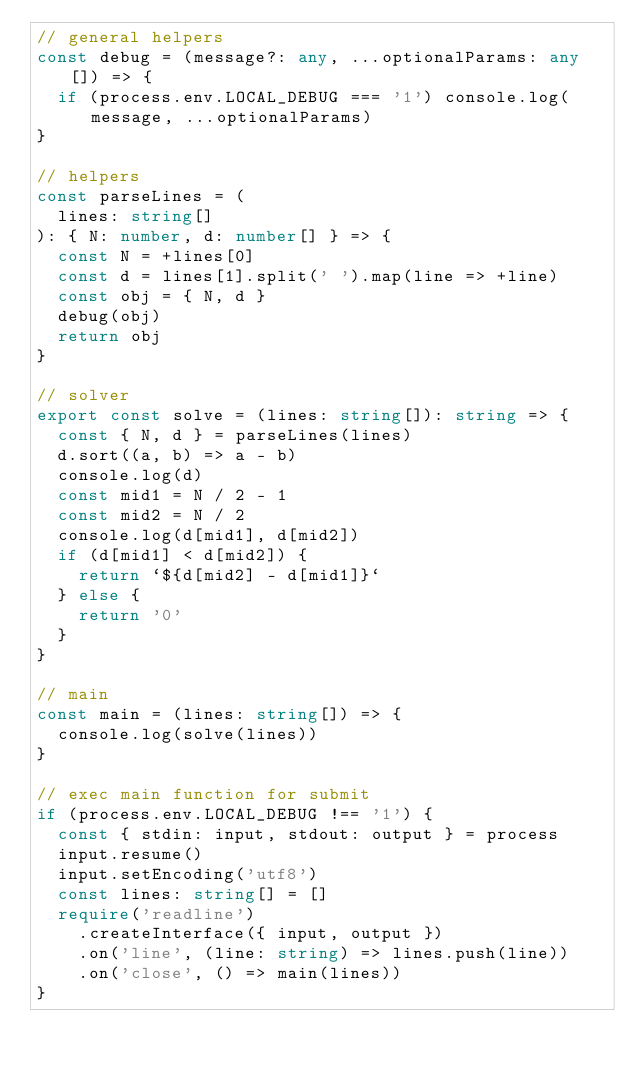Convert code to text. <code><loc_0><loc_0><loc_500><loc_500><_TypeScript_>// general helpers
const debug = (message?: any, ...optionalParams: any[]) => {
  if (process.env.LOCAL_DEBUG === '1') console.log(message, ...optionalParams)
}

// helpers
const parseLines = (
  lines: string[]
): { N: number, d: number[] } => {
  const N = +lines[0]
  const d = lines[1].split(' ').map(line => +line)
  const obj = { N, d }
  debug(obj)
  return obj
}

// solver
export const solve = (lines: string[]): string => {
  const { N, d } = parseLines(lines)
  d.sort((a, b) => a - b)
  console.log(d)
  const mid1 = N / 2 - 1
  const mid2 = N / 2
  console.log(d[mid1], d[mid2])
  if (d[mid1] < d[mid2]) {
    return `${d[mid2] - d[mid1]}`
  } else {
    return '0'
  }
}

// main
const main = (lines: string[]) => {
  console.log(solve(lines))
}

// exec main function for submit
if (process.env.LOCAL_DEBUG !== '1') {
  const { stdin: input, stdout: output } = process
  input.resume()
  input.setEncoding('utf8')
  const lines: string[] = []
  require('readline')
    .createInterface({ input, output })
    .on('line', (line: string) => lines.push(line))
    .on('close', () => main(lines))
}
</code> 